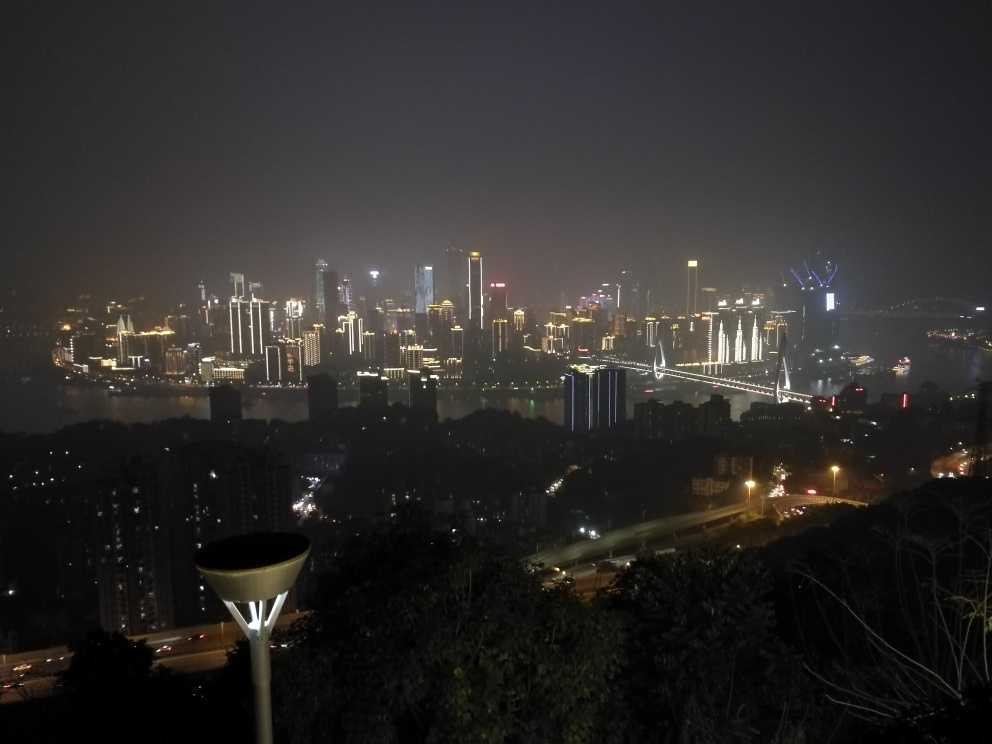What time of day does the image depict, and how does this affect the atmosphere of the scene? The image captures a nighttime scene, which can be deduced from the illuminated buildings and dark sky. The night lighting creates a vibrant and dynamic atmosphere, highlighting the city's architecture and energy. Additionally, the darkness enhances the contrast and makes the lights of the buildings and bridges appear more intense, contributing to a sense of liveliness and activity within the cityscape. 